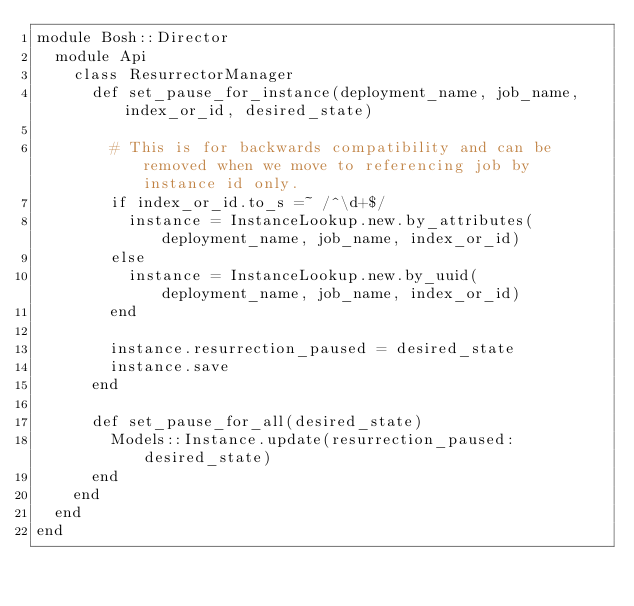<code> <loc_0><loc_0><loc_500><loc_500><_Ruby_>module Bosh::Director
  module Api
    class ResurrectorManager
      def set_pause_for_instance(deployment_name, job_name, index_or_id, desired_state)

        # This is for backwards compatibility and can be removed when we move to referencing job by instance id only.
        if index_or_id.to_s =~ /^\d+$/
          instance = InstanceLookup.new.by_attributes(deployment_name, job_name, index_or_id)
        else
          instance = InstanceLookup.new.by_uuid(deployment_name, job_name, index_or_id)
        end

        instance.resurrection_paused = desired_state
        instance.save
      end

      def set_pause_for_all(desired_state)
        Models::Instance.update(resurrection_paused: desired_state)
      end
    end
  end
end</code> 